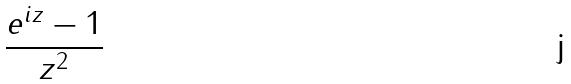<formula> <loc_0><loc_0><loc_500><loc_500>\frac { e ^ { i z } - 1 } { z ^ { 2 } }</formula> 